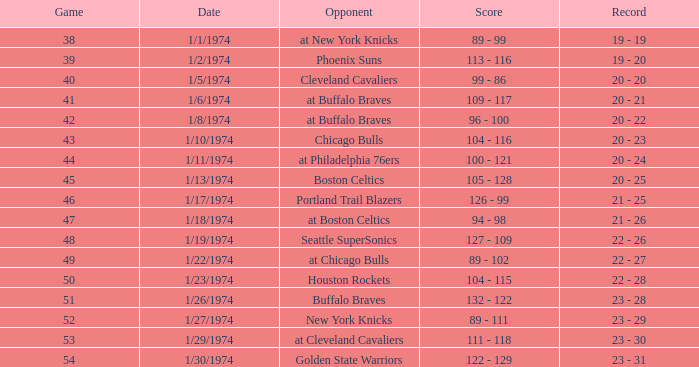What was the score on 1/10/1974? 104 - 116. Give me the full table as a dictionary. {'header': ['Game', 'Date', 'Opponent', 'Score', 'Record'], 'rows': [['38', '1/1/1974', 'at New York Knicks', '89 - 99', '19 - 19'], ['39', '1/2/1974', 'Phoenix Suns', '113 - 116', '19 - 20'], ['40', '1/5/1974', 'Cleveland Cavaliers', '99 - 86', '20 - 20'], ['41', '1/6/1974', 'at Buffalo Braves', '109 - 117', '20 - 21'], ['42', '1/8/1974', 'at Buffalo Braves', '96 - 100', '20 - 22'], ['43', '1/10/1974', 'Chicago Bulls', '104 - 116', '20 - 23'], ['44', '1/11/1974', 'at Philadelphia 76ers', '100 - 121', '20 - 24'], ['45', '1/13/1974', 'Boston Celtics', '105 - 128', '20 - 25'], ['46', '1/17/1974', 'Portland Trail Blazers', '126 - 99', '21 - 25'], ['47', '1/18/1974', 'at Boston Celtics', '94 - 98', '21 - 26'], ['48', '1/19/1974', 'Seattle SuperSonics', '127 - 109', '22 - 26'], ['49', '1/22/1974', 'at Chicago Bulls', '89 - 102', '22 - 27'], ['50', '1/23/1974', 'Houston Rockets', '104 - 115', '22 - 28'], ['51', '1/26/1974', 'Buffalo Braves', '132 - 122', '23 - 28'], ['52', '1/27/1974', 'New York Knicks', '89 - 111', '23 - 29'], ['53', '1/29/1974', 'at Cleveland Cavaliers', '111 - 118', '23 - 30'], ['54', '1/30/1974', 'Golden State Warriors', '122 - 129', '23 - 31']]} 